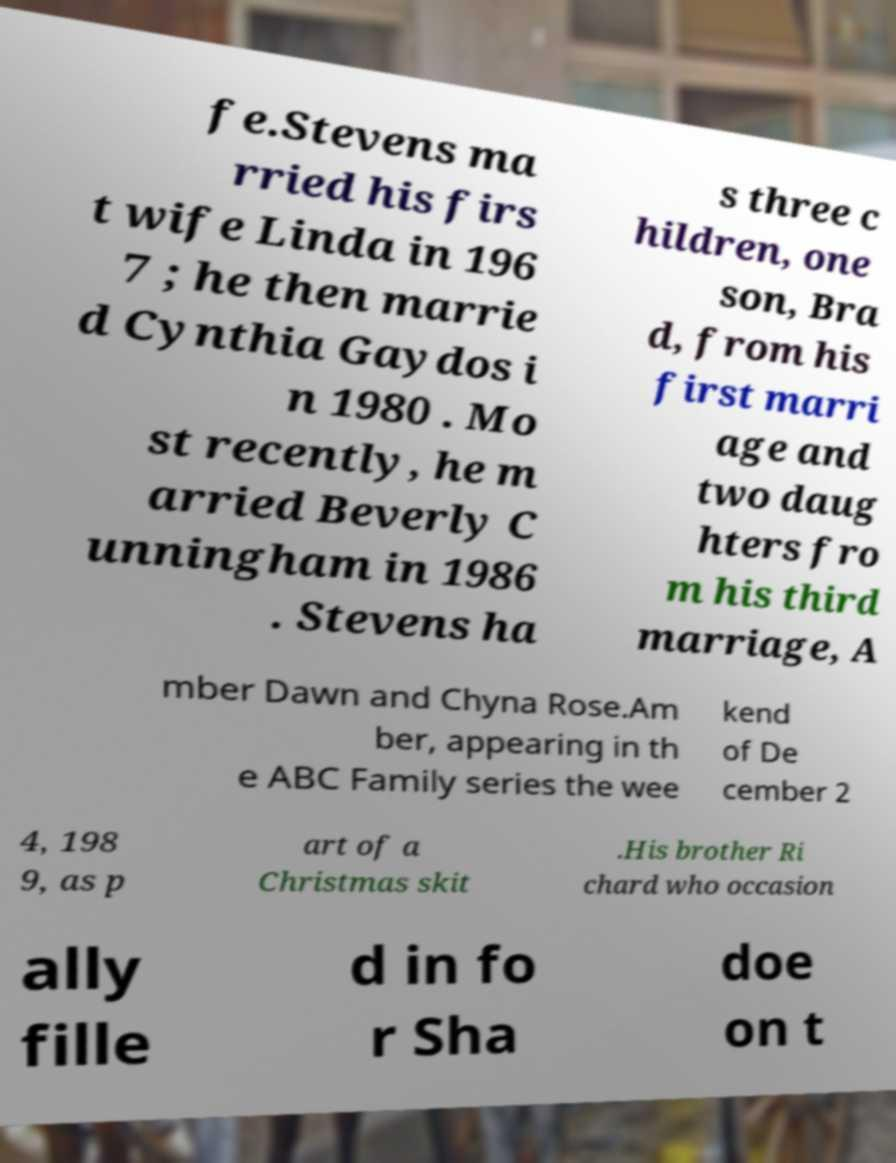I need the written content from this picture converted into text. Can you do that? fe.Stevens ma rried his firs t wife Linda in 196 7 ; he then marrie d Cynthia Gaydos i n 1980 . Mo st recently, he m arried Beverly C unningham in 1986 . Stevens ha s three c hildren, one son, Bra d, from his first marri age and two daug hters fro m his third marriage, A mber Dawn and Chyna Rose.Am ber, appearing in th e ABC Family series the wee kend of De cember 2 4, 198 9, as p art of a Christmas skit .His brother Ri chard who occasion ally fille d in fo r Sha doe on t 